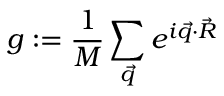Convert formula to latex. <formula><loc_0><loc_0><loc_500><loc_500>g \colon = \frac { 1 } { M } \sum _ { \vec { q } } e ^ { i \vec { q } \cdot \vec { R } }</formula> 